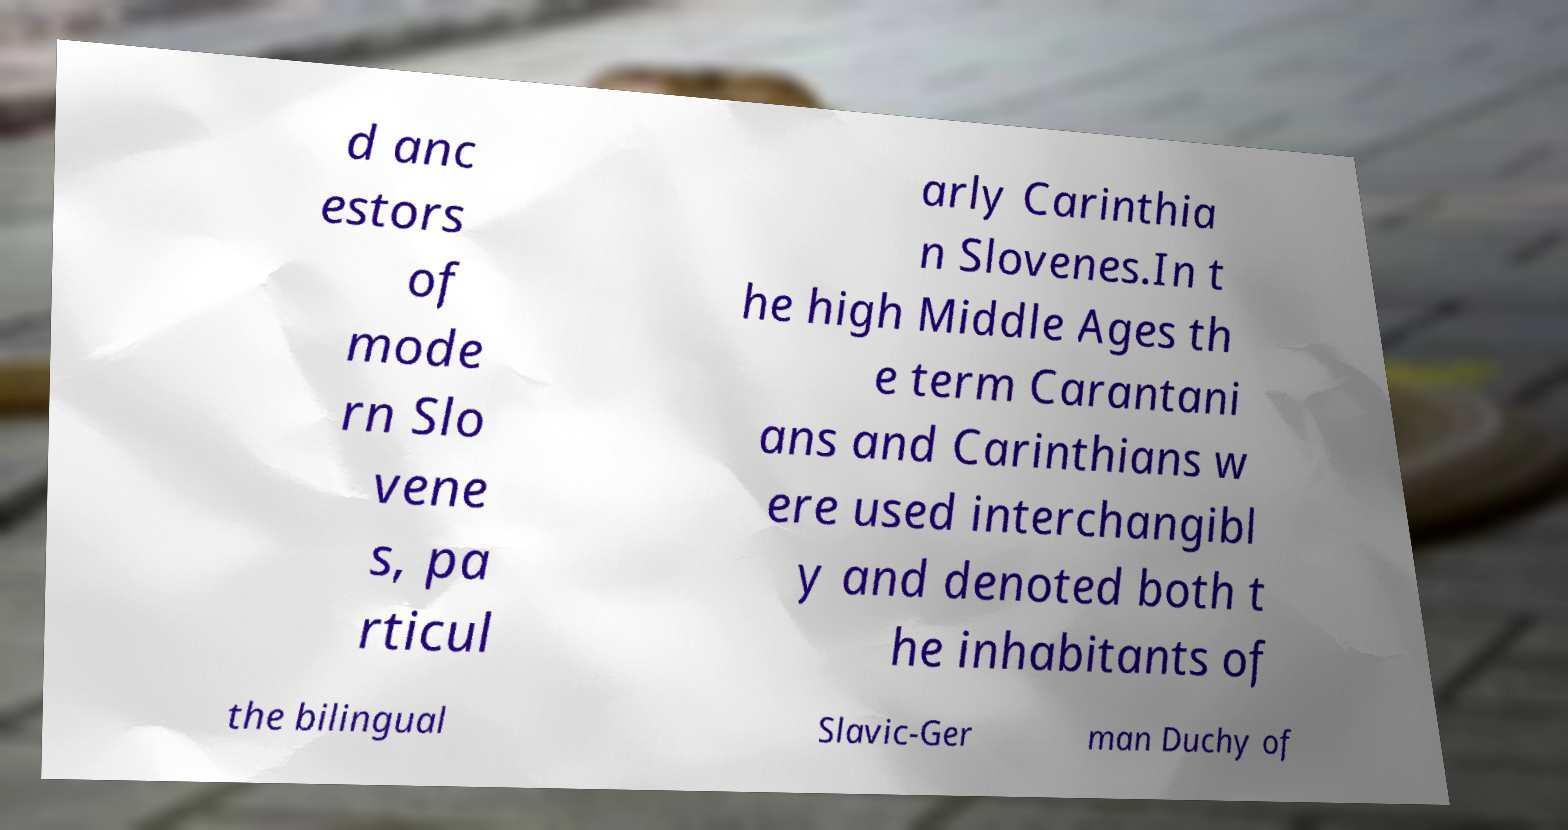Could you extract and type out the text from this image? d anc estors of mode rn Slo vene s, pa rticul arly Carinthia n Slovenes.In t he high Middle Ages th e term Carantani ans and Carinthians w ere used interchangibl y and denoted both t he inhabitants of the bilingual Slavic-Ger man Duchy of 